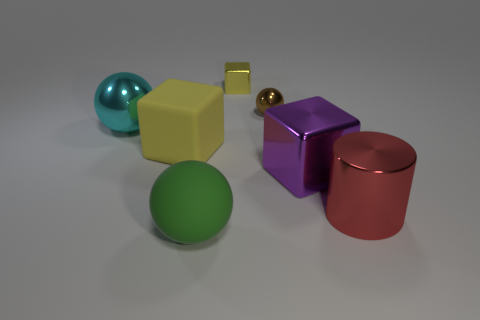Subtract all small yellow metal blocks. How many blocks are left? 2 Subtract 1 cylinders. How many cylinders are left? 0 Add 4 brown cubes. How many brown cubes exist? 4 Add 1 large green matte things. How many objects exist? 8 Subtract all cyan balls. How many balls are left? 2 Subtract 1 cyan balls. How many objects are left? 6 Subtract all cubes. How many objects are left? 4 Subtract all cyan cubes. Subtract all brown cylinders. How many cubes are left? 3 Subtract all blue spheres. How many purple blocks are left? 1 Subtract all large metallic spheres. Subtract all big blue rubber cubes. How many objects are left? 6 